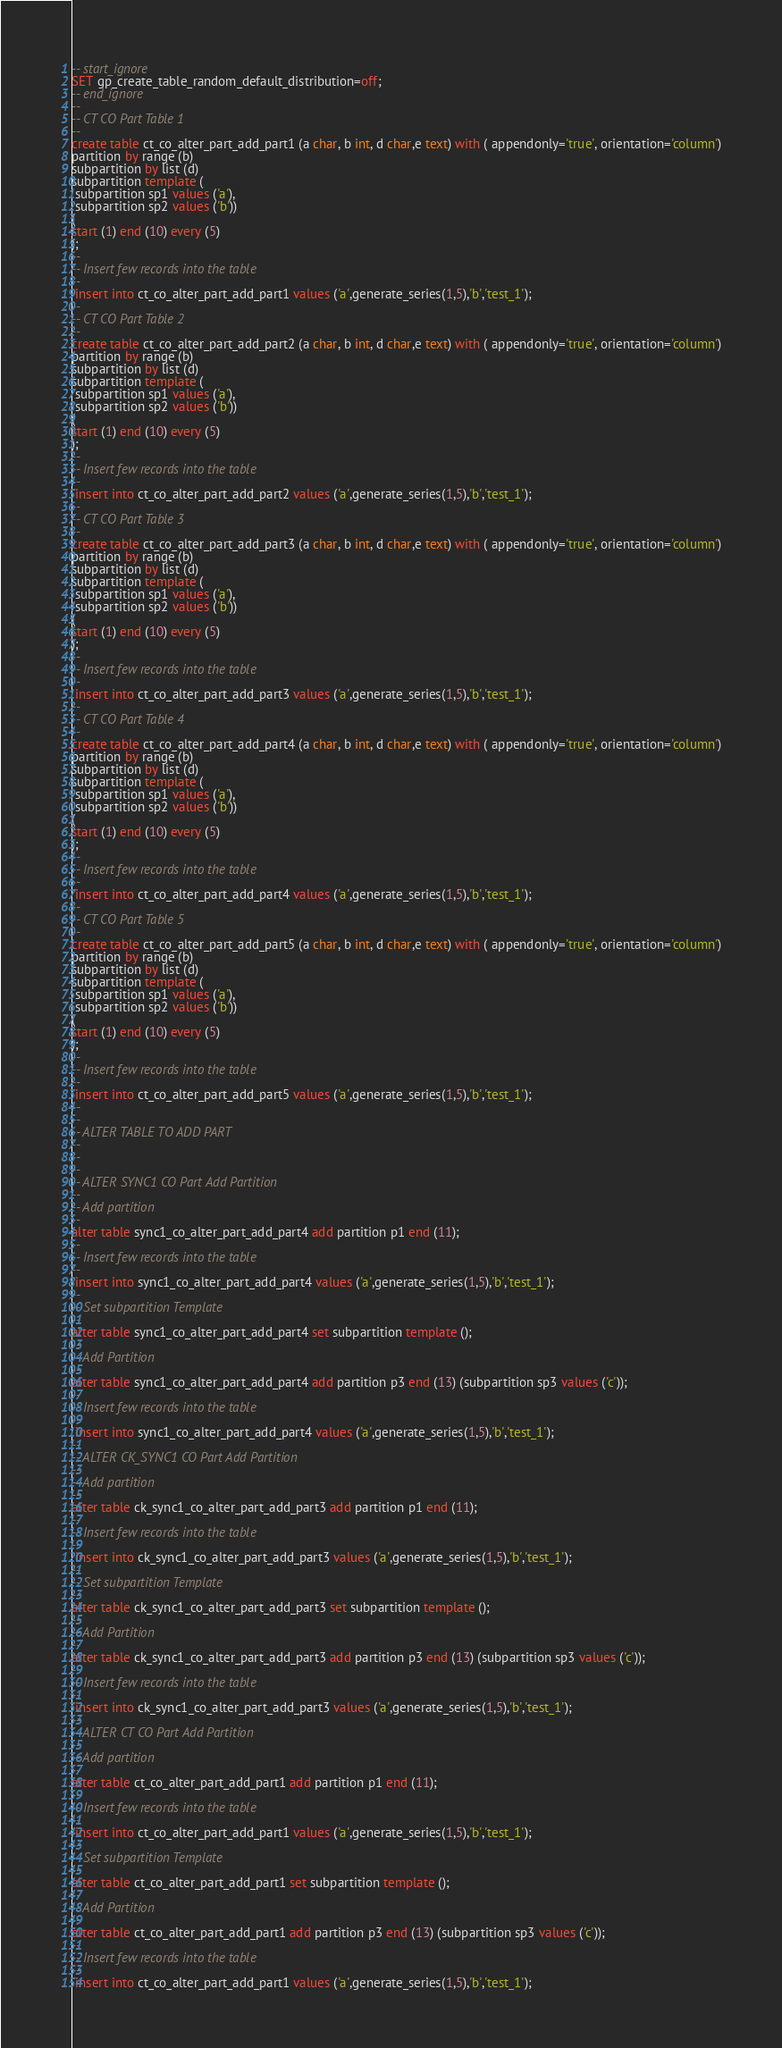<code> <loc_0><loc_0><loc_500><loc_500><_SQL_>-- start_ignore
SET gp_create_table_random_default_distribution=off;
-- end_ignore
--
-- CT CO Part Table 1
--
create table ct_co_alter_part_add_part1 (a char, b int, d char,e text) with ( appendonly='true', orientation='column')
partition by range (b)
subpartition by list (d)
subpartition template (
 subpartition sp1 values ('a'),
 subpartition sp2 values ('b'))
(
start (1) end (10) every (5)
);
--
-- Insert few records into the table
--
 insert into ct_co_alter_part_add_part1 values ('a',generate_series(1,5),'b','test_1');
--
-- CT CO Part Table 2
--
create table ct_co_alter_part_add_part2 (a char, b int, d char,e text) with ( appendonly='true', orientation='column')
partition by range (b)
subpartition by list (d)
subpartition template (
 subpartition sp1 values ('a'),
 subpartition sp2 values ('b'))
(
start (1) end (10) every (5)
);
--
-- Insert few records into the table
--
 insert into ct_co_alter_part_add_part2 values ('a',generate_series(1,5),'b','test_1');
--
-- CT CO Part Table 3
--
create table ct_co_alter_part_add_part3 (a char, b int, d char,e text) with ( appendonly='true', orientation='column')
partition by range (b)
subpartition by list (d)
subpartition template (
 subpartition sp1 values ('a'),
 subpartition sp2 values ('b'))
(
start (1) end (10) every (5)
);
--
-- Insert few records into the table
--
 insert into ct_co_alter_part_add_part3 values ('a',generate_series(1,5),'b','test_1');
--
-- CT CO Part Table 4
--
create table ct_co_alter_part_add_part4 (a char, b int, d char,e text) with ( appendonly='true', orientation='column')
partition by range (b)
subpartition by list (d)
subpartition template (
 subpartition sp1 values ('a'),
 subpartition sp2 values ('b'))
(
start (1) end (10) every (5)
);
--
-- Insert few records into the table
--
 insert into ct_co_alter_part_add_part4 values ('a',generate_series(1,5),'b','test_1');
--
-- CT CO Part Table 5
--
create table ct_co_alter_part_add_part5 (a char, b int, d char,e text) with ( appendonly='true', orientation='column')
partition by range (b)
subpartition by list (d)
subpartition template (
 subpartition sp1 values ('a'),
 subpartition sp2 values ('b'))
(
start (1) end (10) every (5)
);
--
-- Insert few records into the table
--
 insert into ct_co_alter_part_add_part5 values ('a',generate_series(1,5),'b','test_1');
--
--
-- ALTER TABLE TO ADD PART
--
--
--
-- ALTER SYNC1 CO Part Add Partition
--
-- Add partition
--
alter table sync1_co_alter_part_add_part4 add partition p1 end (11);
--
-- Insert few records into the table
--
 insert into sync1_co_alter_part_add_part4 values ('a',generate_series(1,5),'b','test_1');
--
-- Set subpartition Template
--
alter table sync1_co_alter_part_add_part4 set subpartition template ();
--
-- Add Partition
--
alter table sync1_co_alter_part_add_part4 add partition p3 end (13) (subpartition sp3 values ('c'));
--
-- Insert few records into the table
--
 insert into sync1_co_alter_part_add_part4 values ('a',generate_series(1,5),'b','test_1');
--
-- ALTER CK_SYNC1 CO Part Add Partition
--
-- Add partition
--
alter table ck_sync1_co_alter_part_add_part3 add partition p1 end (11);
--
-- Insert few records into the table
--
 insert into ck_sync1_co_alter_part_add_part3 values ('a',generate_series(1,5),'b','test_1');
--
-- Set subpartition Template
--
alter table ck_sync1_co_alter_part_add_part3 set subpartition template ();
--
-- Add Partition
--
alter table ck_sync1_co_alter_part_add_part3 add partition p3 end (13) (subpartition sp3 values ('c'));
--
-- Insert few records into the table
--
 insert into ck_sync1_co_alter_part_add_part3 values ('a',generate_series(1,5),'b','test_1');
--
-- ALTER CT CO Part Add Partition
--
-- Add partition
--
alter table ct_co_alter_part_add_part1 add partition p1 end (11);
--
-- Insert few records into the table
--
 insert into ct_co_alter_part_add_part1 values ('a',generate_series(1,5),'b','test_1');
--
-- Set subpartition Template
--
alter table ct_co_alter_part_add_part1 set subpartition template ();
--
-- Add Partition
--
alter table ct_co_alter_part_add_part1 add partition p3 end (13) (subpartition sp3 values ('c'));
--
-- Insert few records into the table
--
 insert into ct_co_alter_part_add_part1 values ('a',generate_series(1,5),'b','test_1');
</code> 